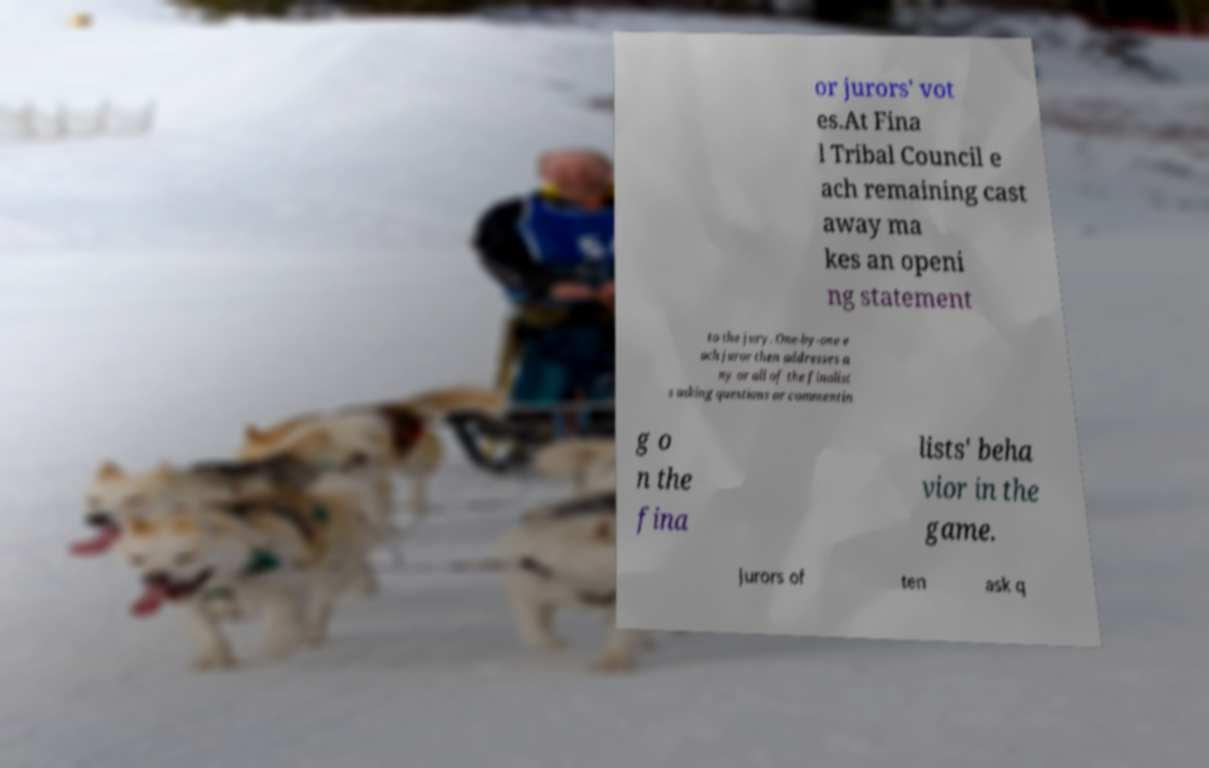Can you accurately transcribe the text from the provided image for me? or jurors' vot es.At Fina l Tribal Council e ach remaining cast away ma kes an openi ng statement to the jury. One-by-one e ach juror then addresses a ny or all of the finalist s asking questions or commentin g o n the fina lists' beha vior in the game. Jurors of ten ask q 